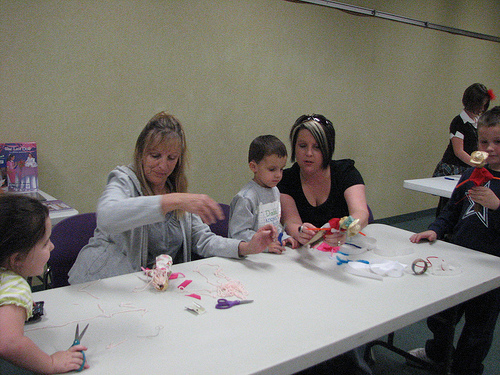<image>
Is the women in front of the table? Yes. The women is positioned in front of the table, appearing closer to the camera viewpoint. 